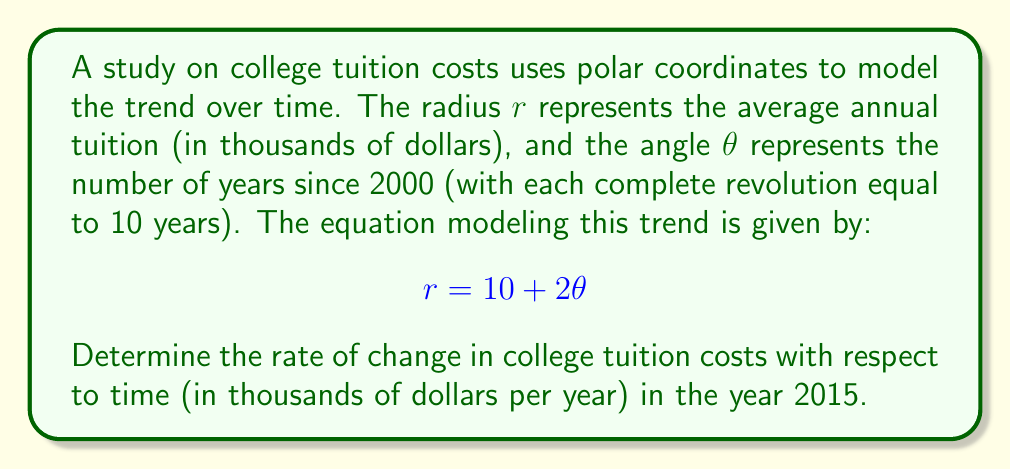Help me with this question. To solve this problem, we need to use polar derivatives and follow these steps:

1) First, we need to find $\frac{dr}{d\theta}$. From the given equation:
   $$r = 10 + 2\theta$$
   $$\frac{dr}{d\theta} = 2$$

2) The general formula for the rate of change of $r$ with respect to time $t$ is:
   $$\frac{dr}{dt} = \frac{dr}{d\theta} \cdot \frac{d\theta}{dt}$$

3) We know that $\frac{dr}{d\theta} = 2$. Now we need to find $\frac{d\theta}{dt}$.

4) Given that one complete revolution (2π radians) represents 10 years:
   $$\frac{d\theta}{dt} = \frac{2\pi}{10} = \frac{\pi}{5} \text{ radians/year}$$

5) Now we can calculate $\frac{dr}{dt}$:
   $$\frac{dr}{dt} = 2 \cdot \frac{\pi}{5} = \frac{2\pi}{5} \text{ thousand dollars/year}$$

6) To convert this to a dollar amount:
   $$\frac{dr}{dt} = \frac{2\pi}{5} \cdot 1000 = \frac{400\pi}{5} \text{ dollars/year}$$

This rate is constant for all years in this model. Therefore, the rate of change in 2015 is the same as any other year.
Answer: The rate of change in college tuition costs in 2015 is $\frac{400\pi}{5} \approx 251.33$ dollars per year. 